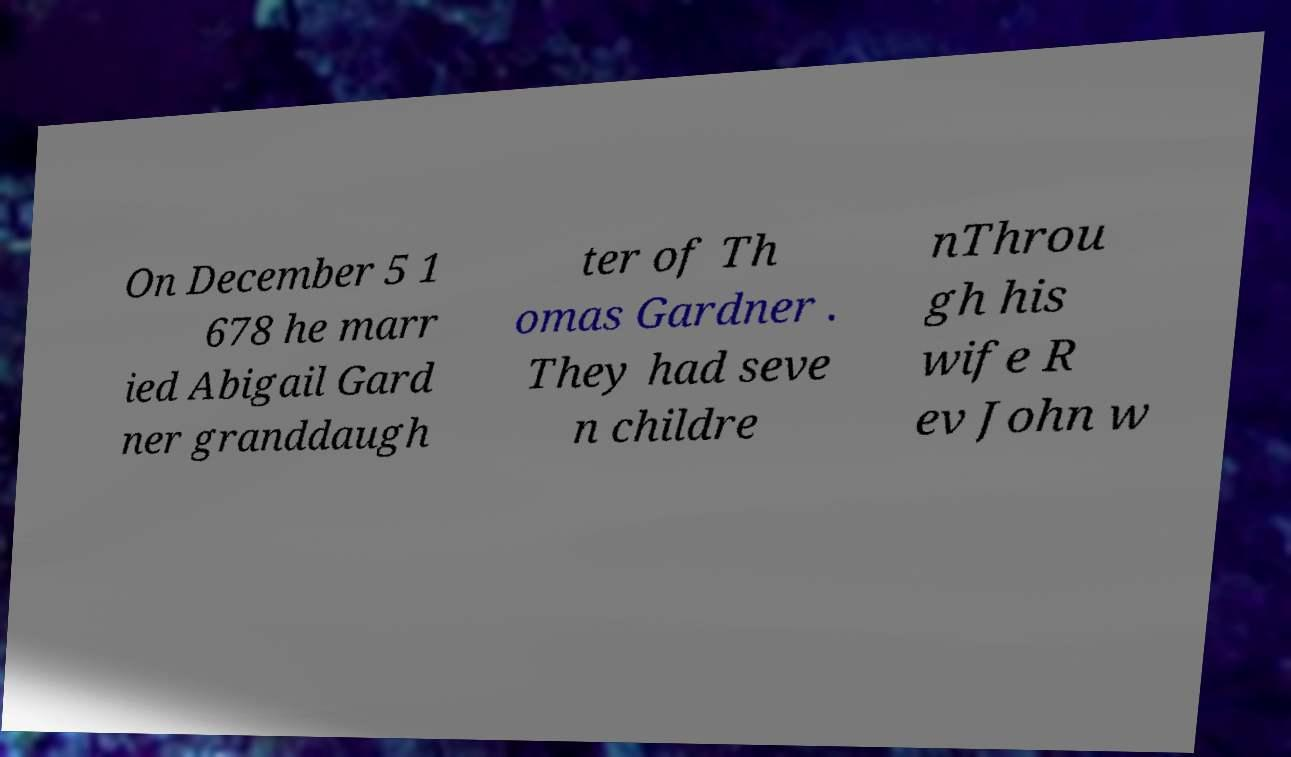There's text embedded in this image that I need extracted. Can you transcribe it verbatim? On December 5 1 678 he marr ied Abigail Gard ner granddaugh ter of Th omas Gardner . They had seve n childre nThrou gh his wife R ev John w 